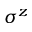Convert formula to latex. <formula><loc_0><loc_0><loc_500><loc_500>\sigma ^ { z }</formula> 